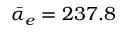<formula> <loc_0><loc_0><loc_500><loc_500>\bar { \alpha } _ { e } = 2 3 7 . 8</formula> 